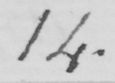Please provide the text content of this handwritten line. 14 . 